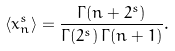<formula> <loc_0><loc_0><loc_500><loc_500>\langle x _ { n } ^ { s } \rangle = \frac { \Gamma ( n + 2 ^ { s } ) } { \Gamma ( 2 ^ { s } ) \, \Gamma ( n + 1 ) } .</formula> 